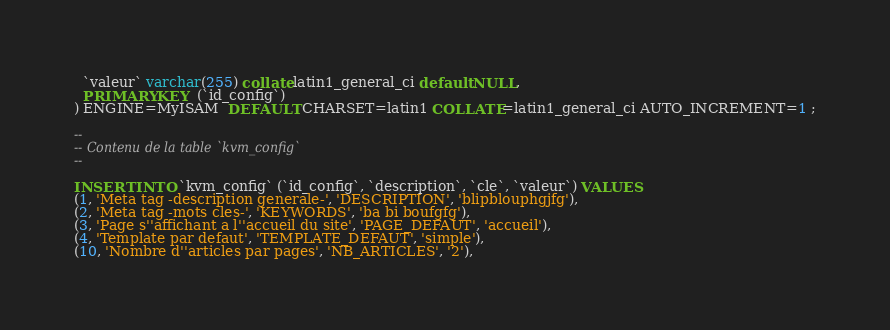Convert code to text. <code><loc_0><loc_0><loc_500><loc_500><_SQL_>  `valeur` varchar(255) collate latin1_general_ci default NULL,
  PRIMARY KEY  (`id_config`)
) ENGINE=MyISAM  DEFAULT CHARSET=latin1 COLLATE=latin1_general_ci AUTO_INCREMENT=1 ;

-- 
-- Contenu de la table `kvm_config`
-- 

INSERT INTO `kvm_config` (`id_config`, `description`, `cle`, `valeur`) VALUES 
(1, 'Meta tag -description generale-', 'DESCRIPTION', 'blipblouphgjfg'),
(2, 'Meta tag -mots cles-', 'KEYWORDS', 'ba bi boufgfg'),
(3, 'Page s''affichant a l''accueil du site', 'PAGE_DEFAUT', 'accueil'),
(4, 'Template par defaut', 'TEMPLATE_DEFAUT', 'simple'),
(10, 'Nombre d''articles par pages', 'NB_ARTICLES', '2'),</code> 